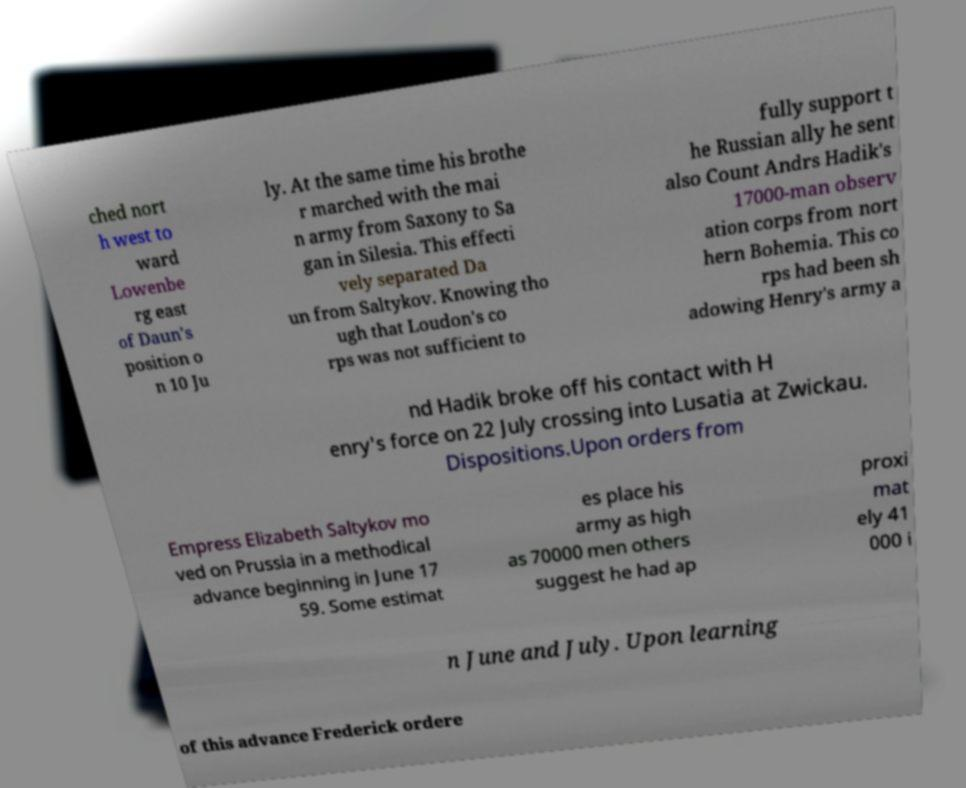There's text embedded in this image that I need extracted. Can you transcribe it verbatim? ched nort h west to ward Lowenbe rg east of Daun's position o n 10 Ju ly. At the same time his brothe r marched with the mai n army from Saxony to Sa gan in Silesia. This effecti vely separated Da un from Saltykov. Knowing tho ugh that Loudon's co rps was not sufficient to fully support t he Russian ally he sent also Count Andrs Hadik's 17000-man observ ation corps from nort hern Bohemia. This co rps had been sh adowing Henry's army a nd Hadik broke off his contact with H enry's force on 22 July crossing into Lusatia at Zwickau. Dispositions.Upon orders from Empress Elizabeth Saltykov mo ved on Prussia in a methodical advance beginning in June 17 59. Some estimat es place his army as high as 70000 men others suggest he had ap proxi mat ely 41 000 i n June and July. Upon learning of this advance Frederick ordere 